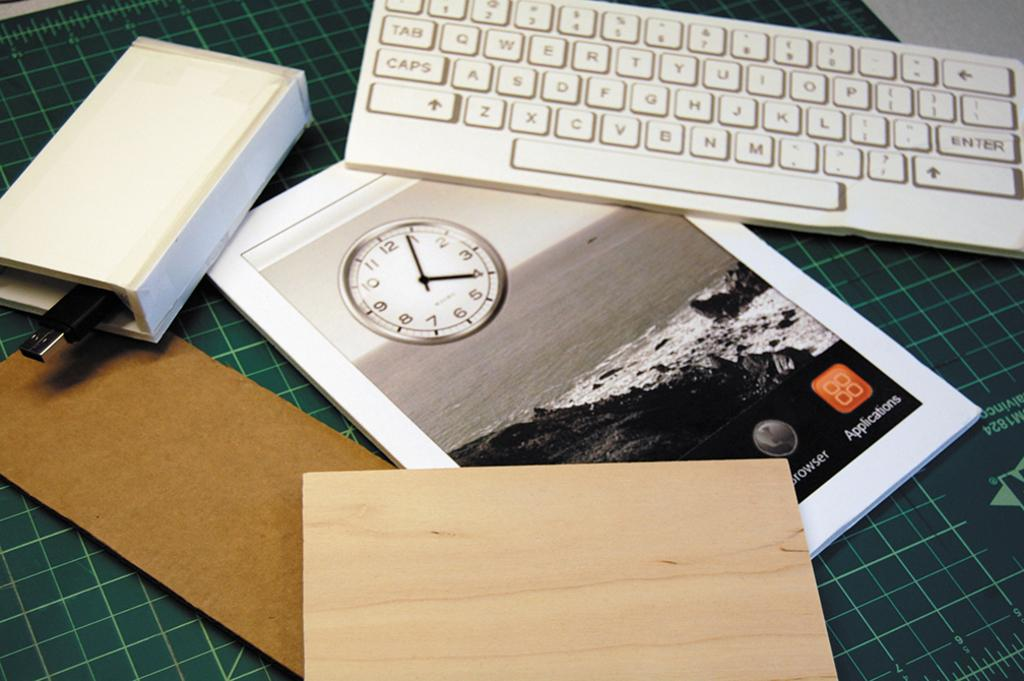Provide a one-sentence caption for the provided image. A keyboard and a book about applications on a table. 